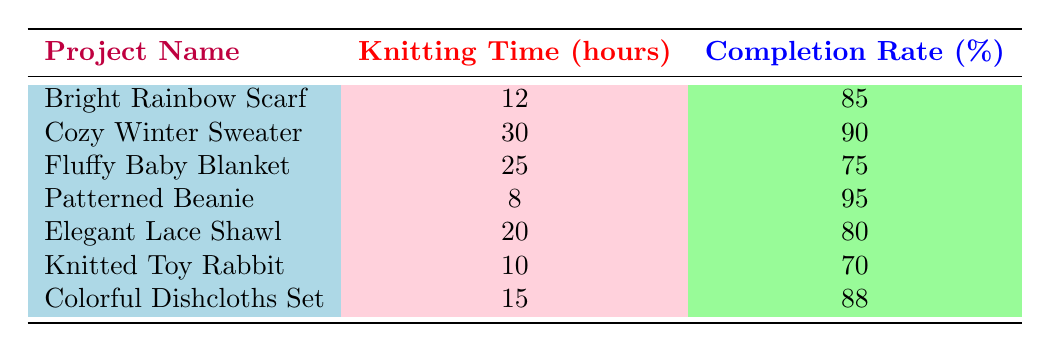What is the completion rate of the Patterned Beanie? According to the table, the Patterned Beanie has a completion rate percentage of 95.
Answer: 95 How many hours did it take to knit the Cozy Winter Sweater? The table shows that the Cozy Winter Sweater required 30 knitting hours.
Answer: 30 Which project has the highest knitting time, and what is its completion rate? The Cozy Winter Sweater has the highest knitting time at 30 hours, and its completion rate is 90%.
Answer: Cozy Winter Sweater, 90 What is the average completion rate of all knitting projects? To find the average, add all completion rates: (85 + 90 + 75 + 95 + 80 + 70 + 88) =  683. There are 7 projects, so the average is 683/7 = 97.57. Therefore, the average completion rate is approximately 84.71%.
Answer: 84.71 Is the completion rate for the Fluffy Baby Blanket greater than 80%? The completion rate for the Fluffy Baby Blanket is 75%, which is not greater than 80%.
Answer: No Are there any projects that took less than 15 hours to knit? Yes, both the Patterned Beanie (8 hours) and the Knitted Toy Rabbit (10 hours) took less than 15 hours.
Answer: Yes What is the difference in completion rates between the Fluffy Baby Blanket and the Colorful Dishcloths Set? The completion rate for the Fluffy Baby Blanket is 75%, while the Colorful Dishcloths Set is 88%. The difference is 88 - 75 = 13.
Answer: 13 Which project has a higher completion rate, the Elegant Lace Shawl or the Bright Rainbow Scarf? The Elegant Lace Shawl has a completion rate of 80%, while the Bright Rainbow Scarf has a completion rate of 85%. Since 85 is greater than 80, the Bright Rainbow Scarf has the higher completion rate.
Answer: Bright Rainbow Scarf If all projects were completed, what is the total knitting time spent? Add all the knitting hours: (12 + 30 + 25 + 8 + 20 + 10 + 15) = 120 hours total was spent on knitting all projects.
Answer: 120 